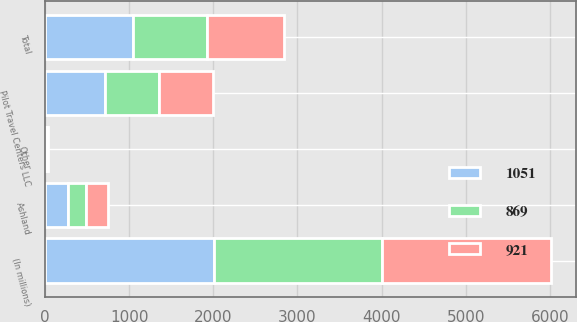Convert chart to OTSL. <chart><loc_0><loc_0><loc_500><loc_500><stacked_bar_chart><ecel><fcel>(In millions)<fcel>Ashland<fcel>Pilot Travel Centers LLC<fcel>Other<fcel>Total<nl><fcel>1051<fcel>2004<fcel>274<fcel>715<fcel>13<fcel>1051<nl><fcel>921<fcel>2003<fcel>258<fcel>635<fcel>12<fcel>921<nl><fcel>869<fcel>2002<fcel>218<fcel>645<fcel>6<fcel>869<nl></chart> 